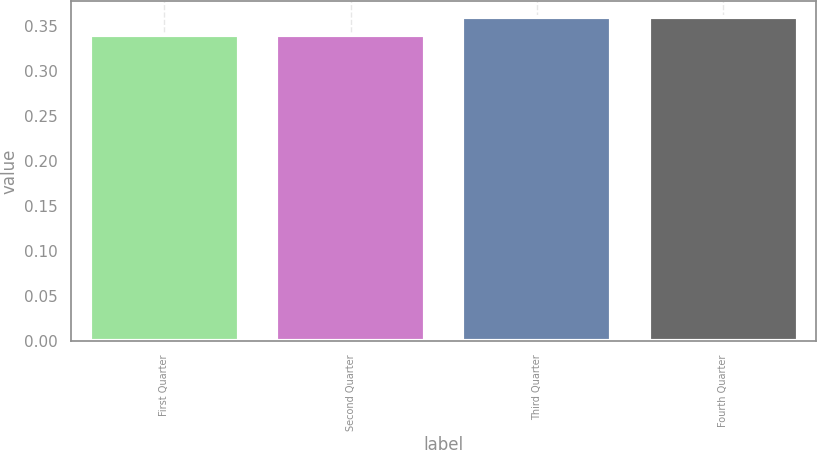Convert chart. <chart><loc_0><loc_0><loc_500><loc_500><bar_chart><fcel>First Quarter<fcel>Second Quarter<fcel>Third Quarter<fcel>Fourth Quarter<nl><fcel>0.34<fcel>0.34<fcel>0.36<fcel>0.36<nl></chart> 